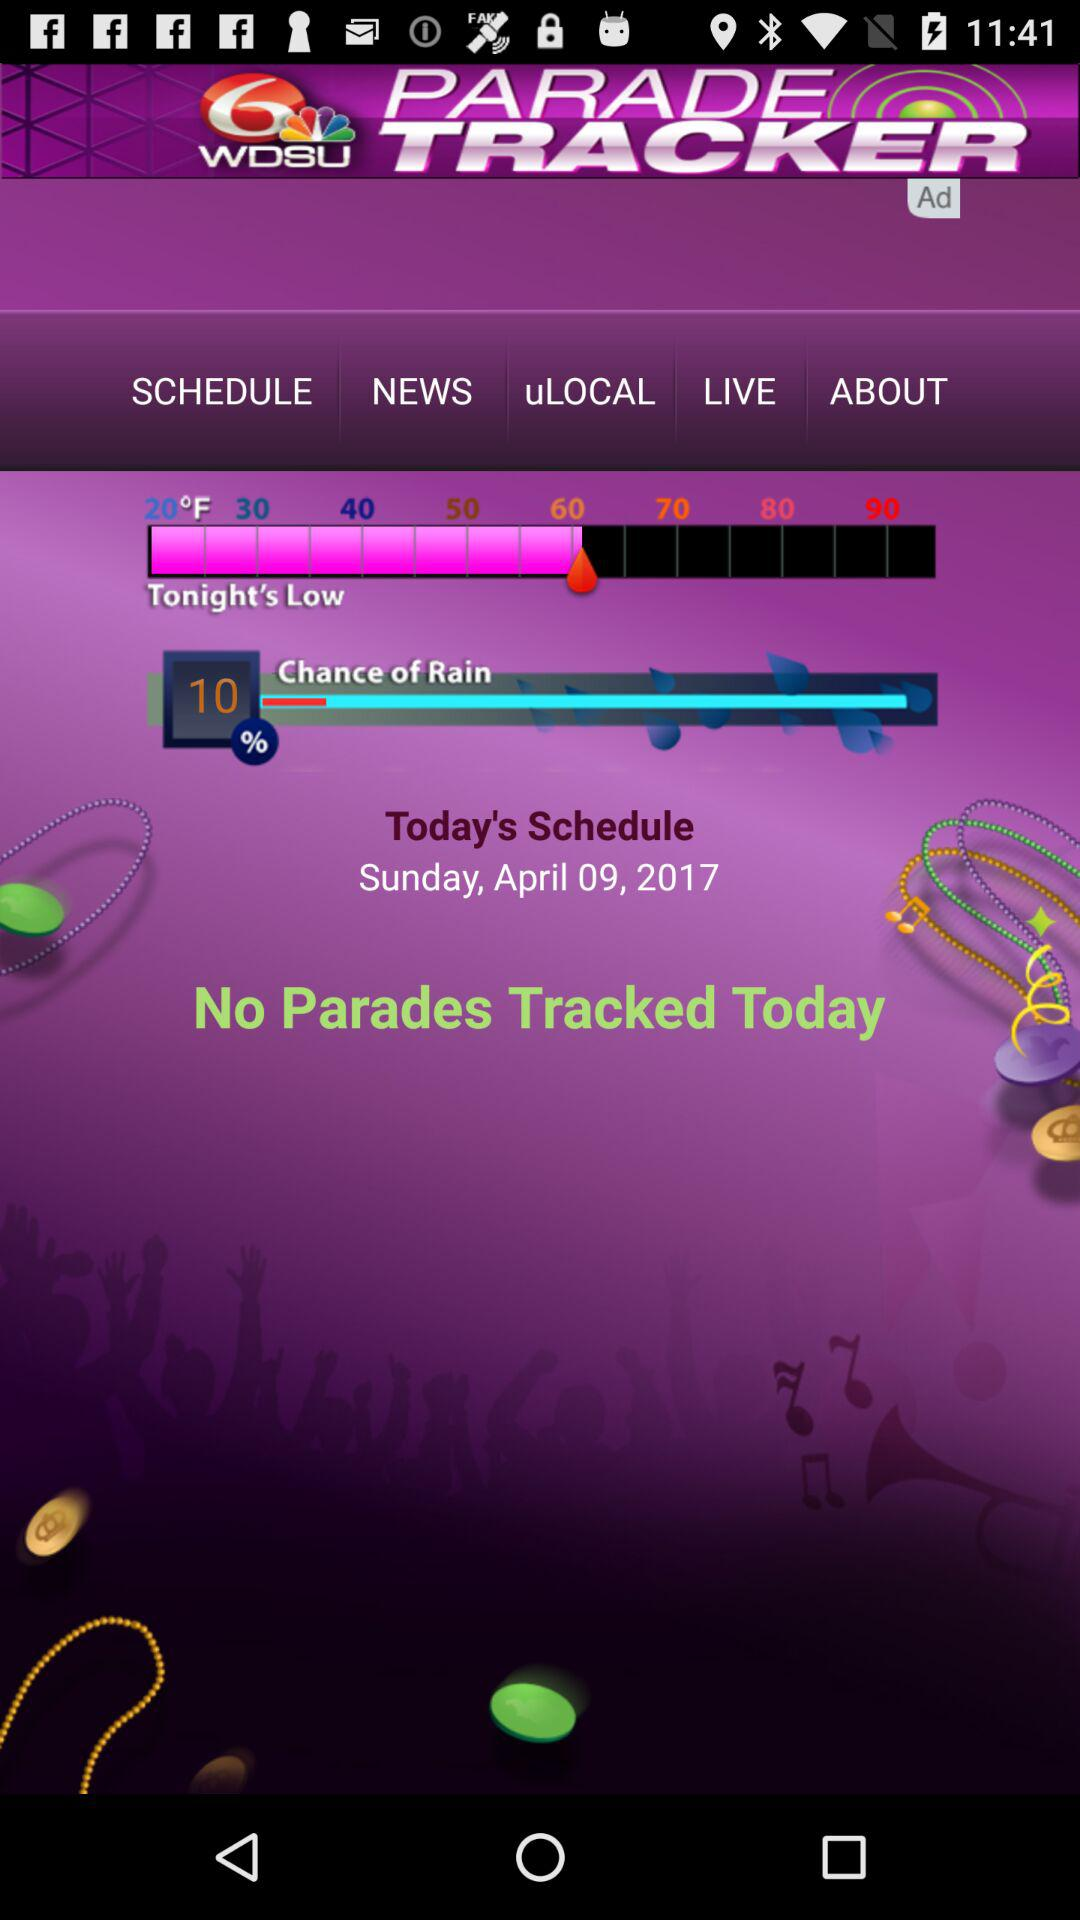What are the chances of rain today? The chances of rain today is 10%. 